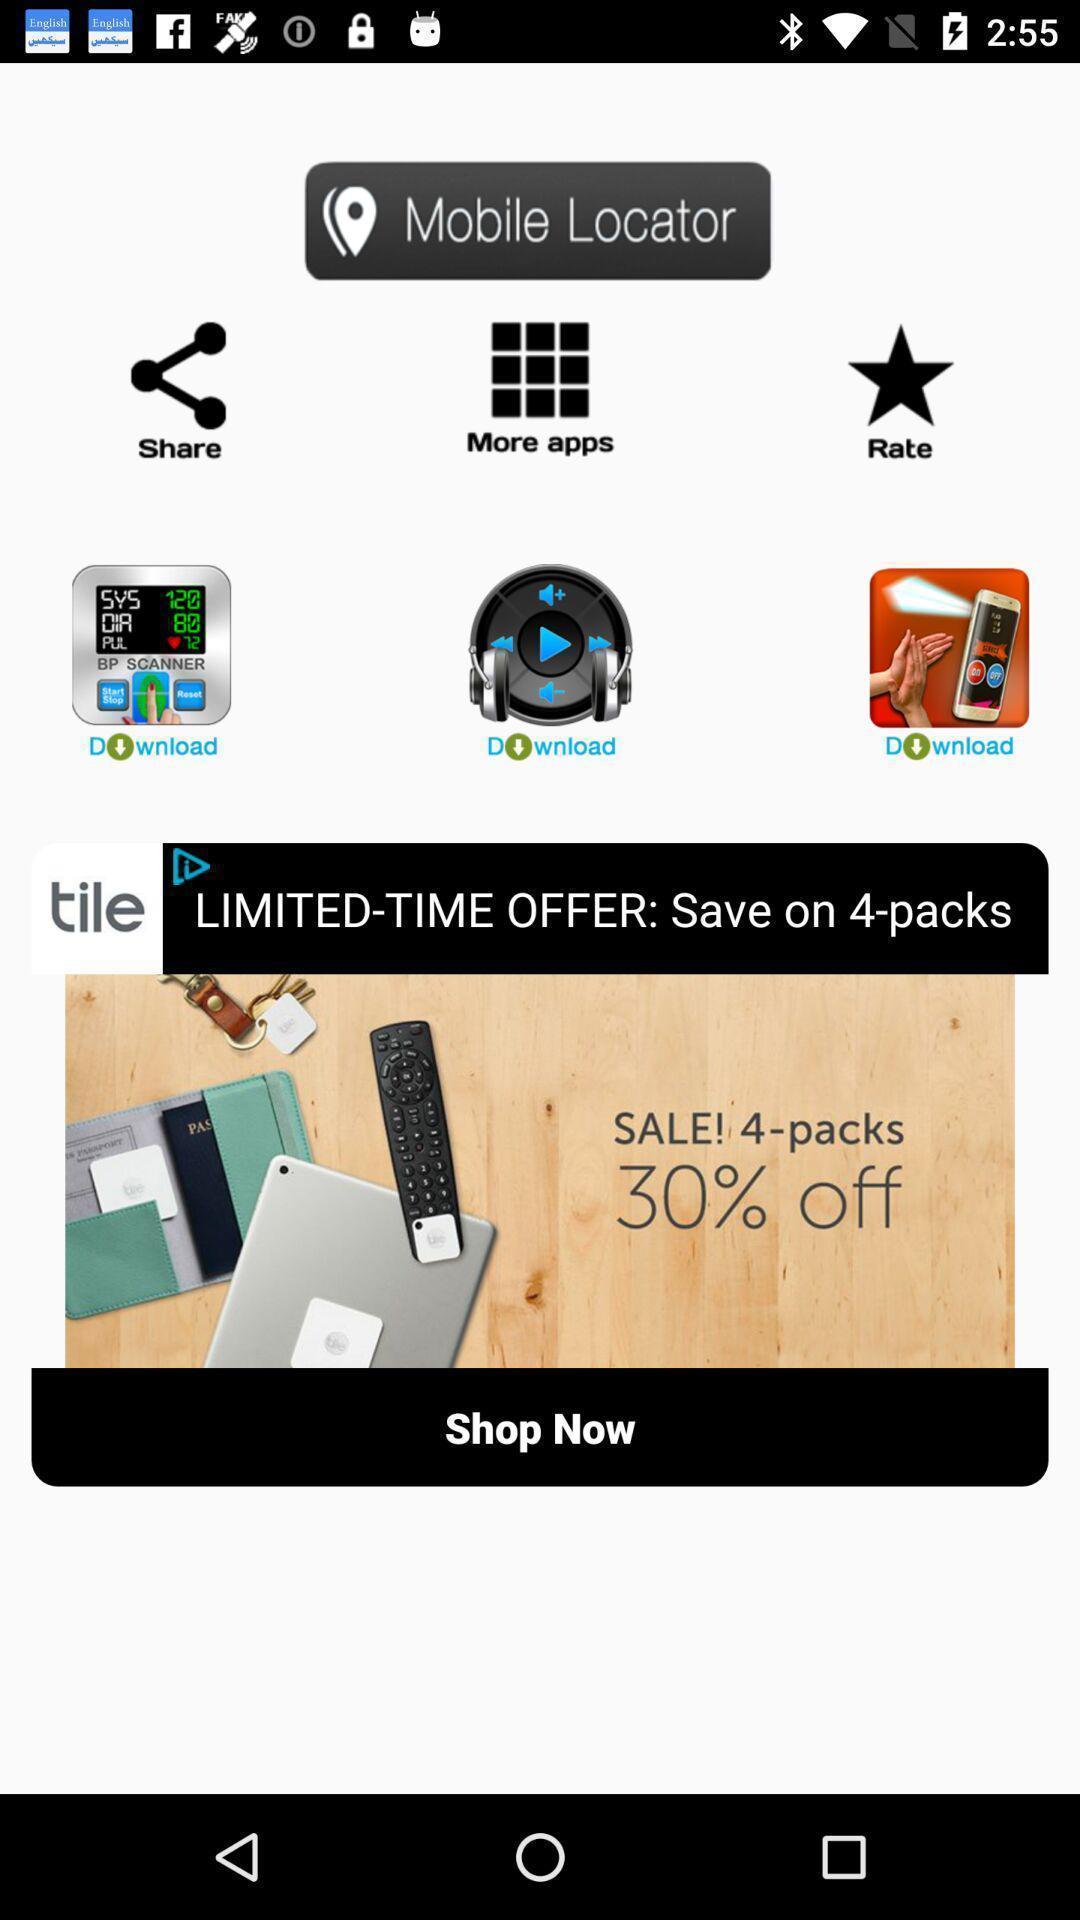Please provide a description for this image. Shopping application advertisement displaying in this page. 